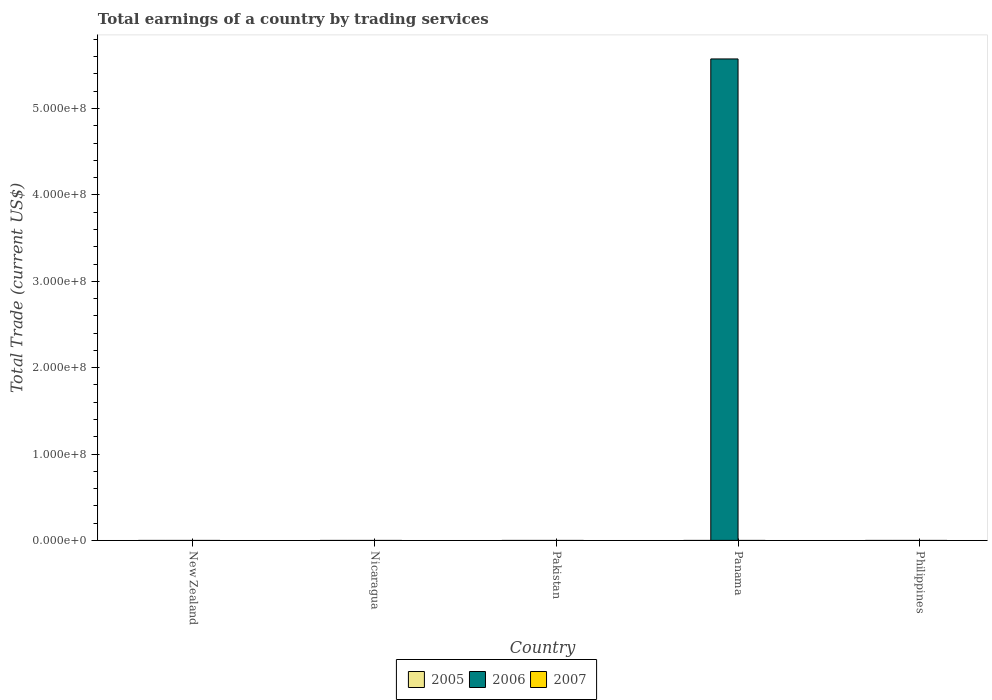How many different coloured bars are there?
Your answer should be compact. 1. Are the number of bars per tick equal to the number of legend labels?
Your response must be concise. No. How many bars are there on the 1st tick from the right?
Give a very brief answer. 0. What is the label of the 1st group of bars from the left?
Offer a terse response. New Zealand. In how many cases, is the number of bars for a given country not equal to the number of legend labels?
Your answer should be compact. 5. What is the total earnings in 2005 in Panama?
Provide a succinct answer. 0. Across all countries, what is the maximum total earnings in 2006?
Your response must be concise. 5.57e+08. Across all countries, what is the minimum total earnings in 2007?
Provide a succinct answer. 0. In which country was the total earnings in 2006 maximum?
Provide a succinct answer. Panama. What is the total total earnings in 2006 in the graph?
Give a very brief answer. 5.57e+08. What is the difference between the total earnings in 2006 in New Zealand and the total earnings in 2007 in Panama?
Offer a terse response. 0. What is the average total earnings in 2007 per country?
Ensure brevity in your answer.  0. In how many countries, is the total earnings in 2006 greater than 180000000 US$?
Provide a succinct answer. 1. What is the difference between the highest and the lowest total earnings in 2006?
Your response must be concise. 5.57e+08. In how many countries, is the total earnings in 2007 greater than the average total earnings in 2007 taken over all countries?
Keep it short and to the point. 0. Are all the bars in the graph horizontal?
Give a very brief answer. No. How many countries are there in the graph?
Provide a short and direct response. 5. Does the graph contain grids?
Your answer should be very brief. No. How are the legend labels stacked?
Make the answer very short. Horizontal. What is the title of the graph?
Offer a very short reply. Total earnings of a country by trading services. What is the label or title of the Y-axis?
Your answer should be very brief. Total Trade (current US$). What is the Total Trade (current US$) in 2005 in New Zealand?
Offer a very short reply. 0. What is the Total Trade (current US$) in 2007 in New Zealand?
Keep it short and to the point. 0. What is the Total Trade (current US$) of 2005 in Nicaragua?
Your answer should be compact. 0. What is the Total Trade (current US$) in 2007 in Nicaragua?
Offer a terse response. 0. What is the Total Trade (current US$) in 2006 in Panama?
Make the answer very short. 5.57e+08. What is the Total Trade (current US$) in 2006 in Philippines?
Keep it short and to the point. 0. Across all countries, what is the maximum Total Trade (current US$) of 2006?
Your answer should be compact. 5.57e+08. Across all countries, what is the minimum Total Trade (current US$) of 2006?
Your answer should be very brief. 0. What is the total Total Trade (current US$) of 2006 in the graph?
Ensure brevity in your answer.  5.57e+08. What is the total Total Trade (current US$) in 2007 in the graph?
Provide a short and direct response. 0. What is the average Total Trade (current US$) of 2006 per country?
Provide a succinct answer. 1.11e+08. What is the difference between the highest and the lowest Total Trade (current US$) of 2006?
Make the answer very short. 5.57e+08. 